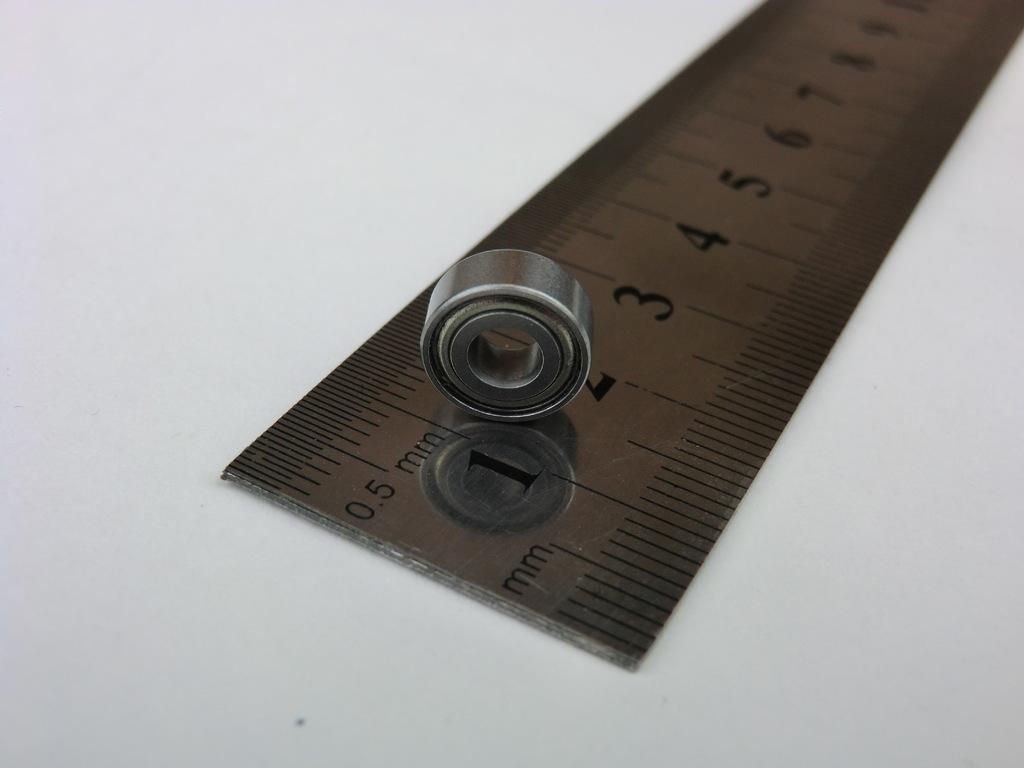<image>
Render a clear and concise summary of the photo. the numbers 1 and 2 are on a ruler 